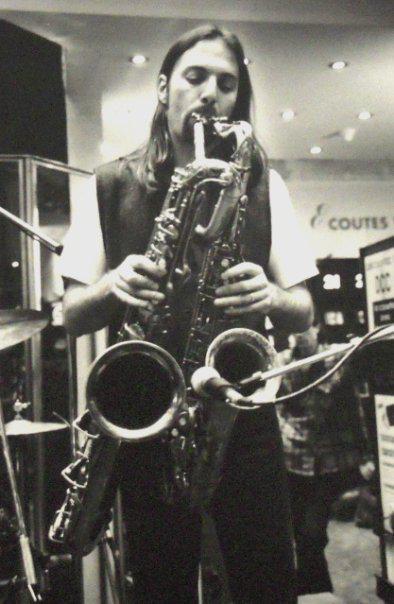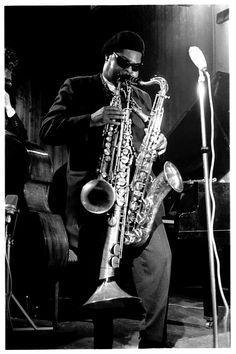The first image is the image on the left, the second image is the image on the right. For the images displayed, is the sentence "Two men are in front of microphones, one playing two saxophones and one playing three, with no other persons seen playing any instruments." factually correct? Answer yes or no. Yes. 